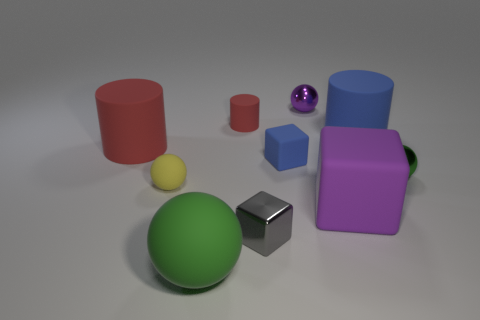Subtract all brown balls. Subtract all red cylinders. How many balls are left? 4 Subtract all cubes. How many objects are left? 7 Subtract 1 blue cubes. How many objects are left? 9 Subtract all large metallic things. Subtract all tiny blue rubber objects. How many objects are left? 9 Add 4 tiny green objects. How many tiny green objects are left? 5 Add 8 red cylinders. How many red cylinders exist? 10 